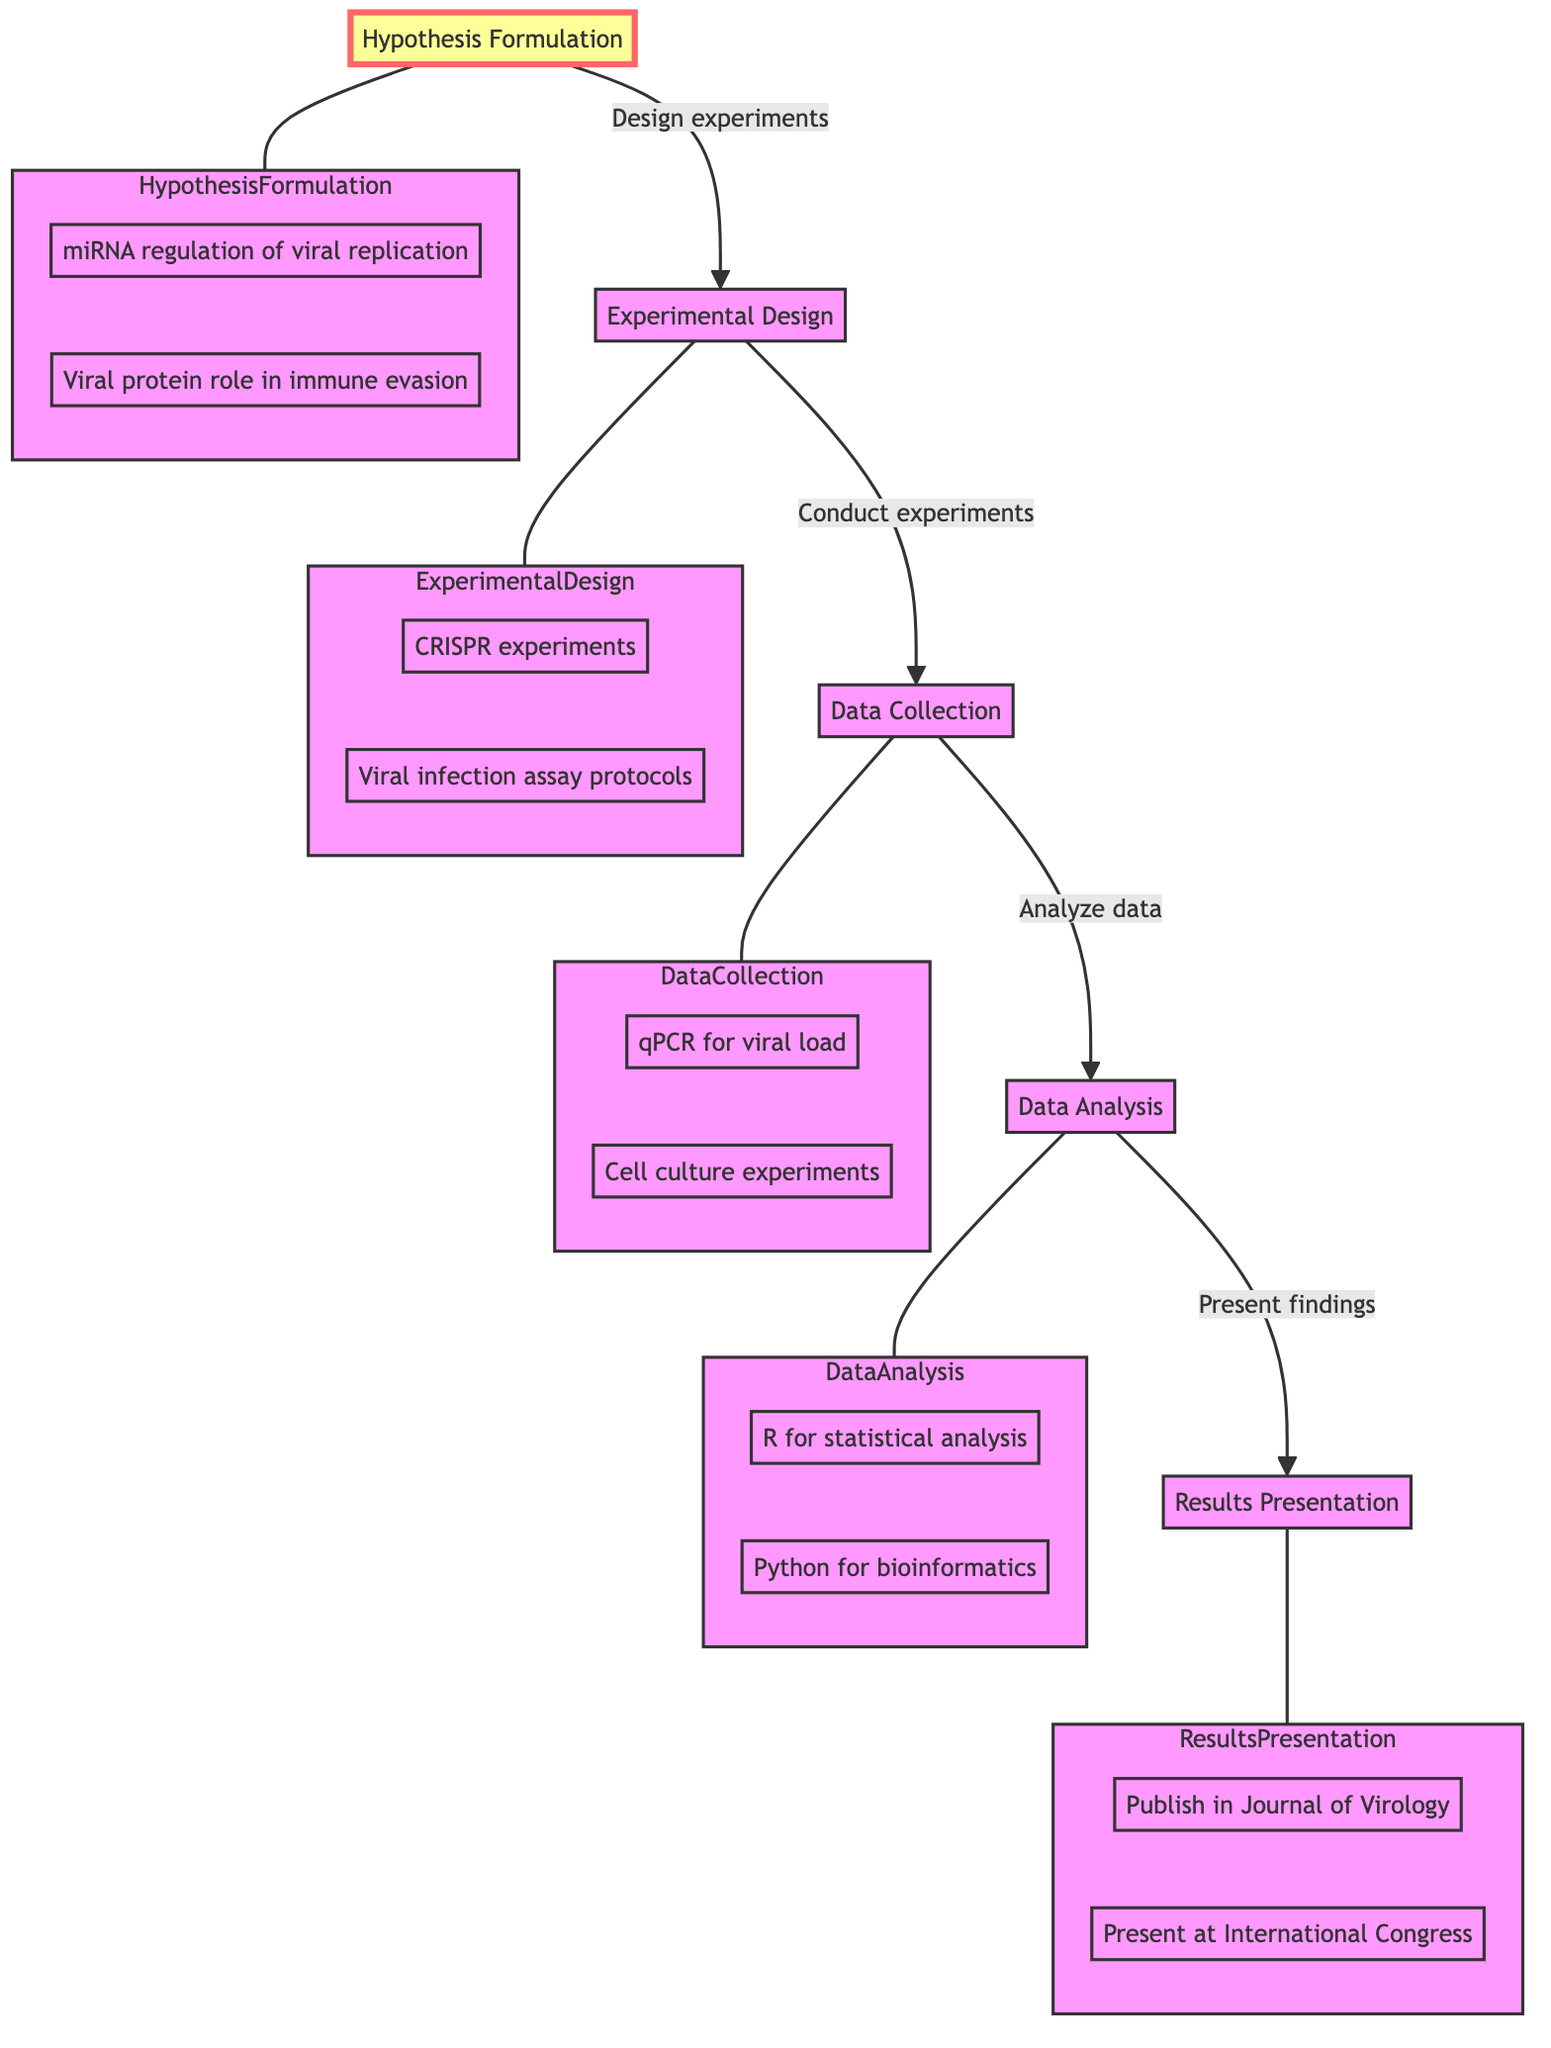What is the first step in the research project management flow? The first step is labeled as "Hypothesis Formulation," which is the starting point of the flowchart, indicating the initiation of the research project.
Answer: Hypothesis Formulation How many main steps are in the flowchart? There are five main steps in the flowchart: Hypothesis Formulation, Experimental Design, Data Collection, Data Analysis, and Results Presentation.
Answer: Five What does the arrow from "Hypothesis Formulation" point to? The arrow from "Hypothesis Formulation" points to "Experimental Design," indicating that the experimental design is the next process after formulating hypotheses.
Answer: Experimental Design Which method is used for statistical analysis in the Data Analysis step? The method used for statistical analysis is "R," which is explicitly mentioned as one of the examples in the Data Analysis section.
Answer: R What is the final step before results presentation? The final step before Results Presentation is "Data Analysis." This indicates that analysis must be completed before findings can be presented.
Answer: Data Analysis Which hypothesis investigates the role of a viral protein? The hypothesis that investigates the role of a viral protein is "Investigate the role of a viral protein in immune evasion," stated under Hypothesis Formulation.
Answer: Investigate the role of a viral protein in immune evasion What type of experiment is designed for studying gene function in viruses? The experiment designed for studying gene function in viruses is "CRISPR experiments," which is listed under Experimental Design.
Answer: CRISPR experiments From which step do you collect data? Data is collected from the step labeled "Data Collection," which follows Experimental Design according to the flow of the diagram.
Answer: Data Collection What is one of the examples of data collection methods? One of the examples of data collection methods is "qPCR to quantify viral load," as shown in the Data Collection section of the diagram.
Answer: qPCR to quantify viral load 